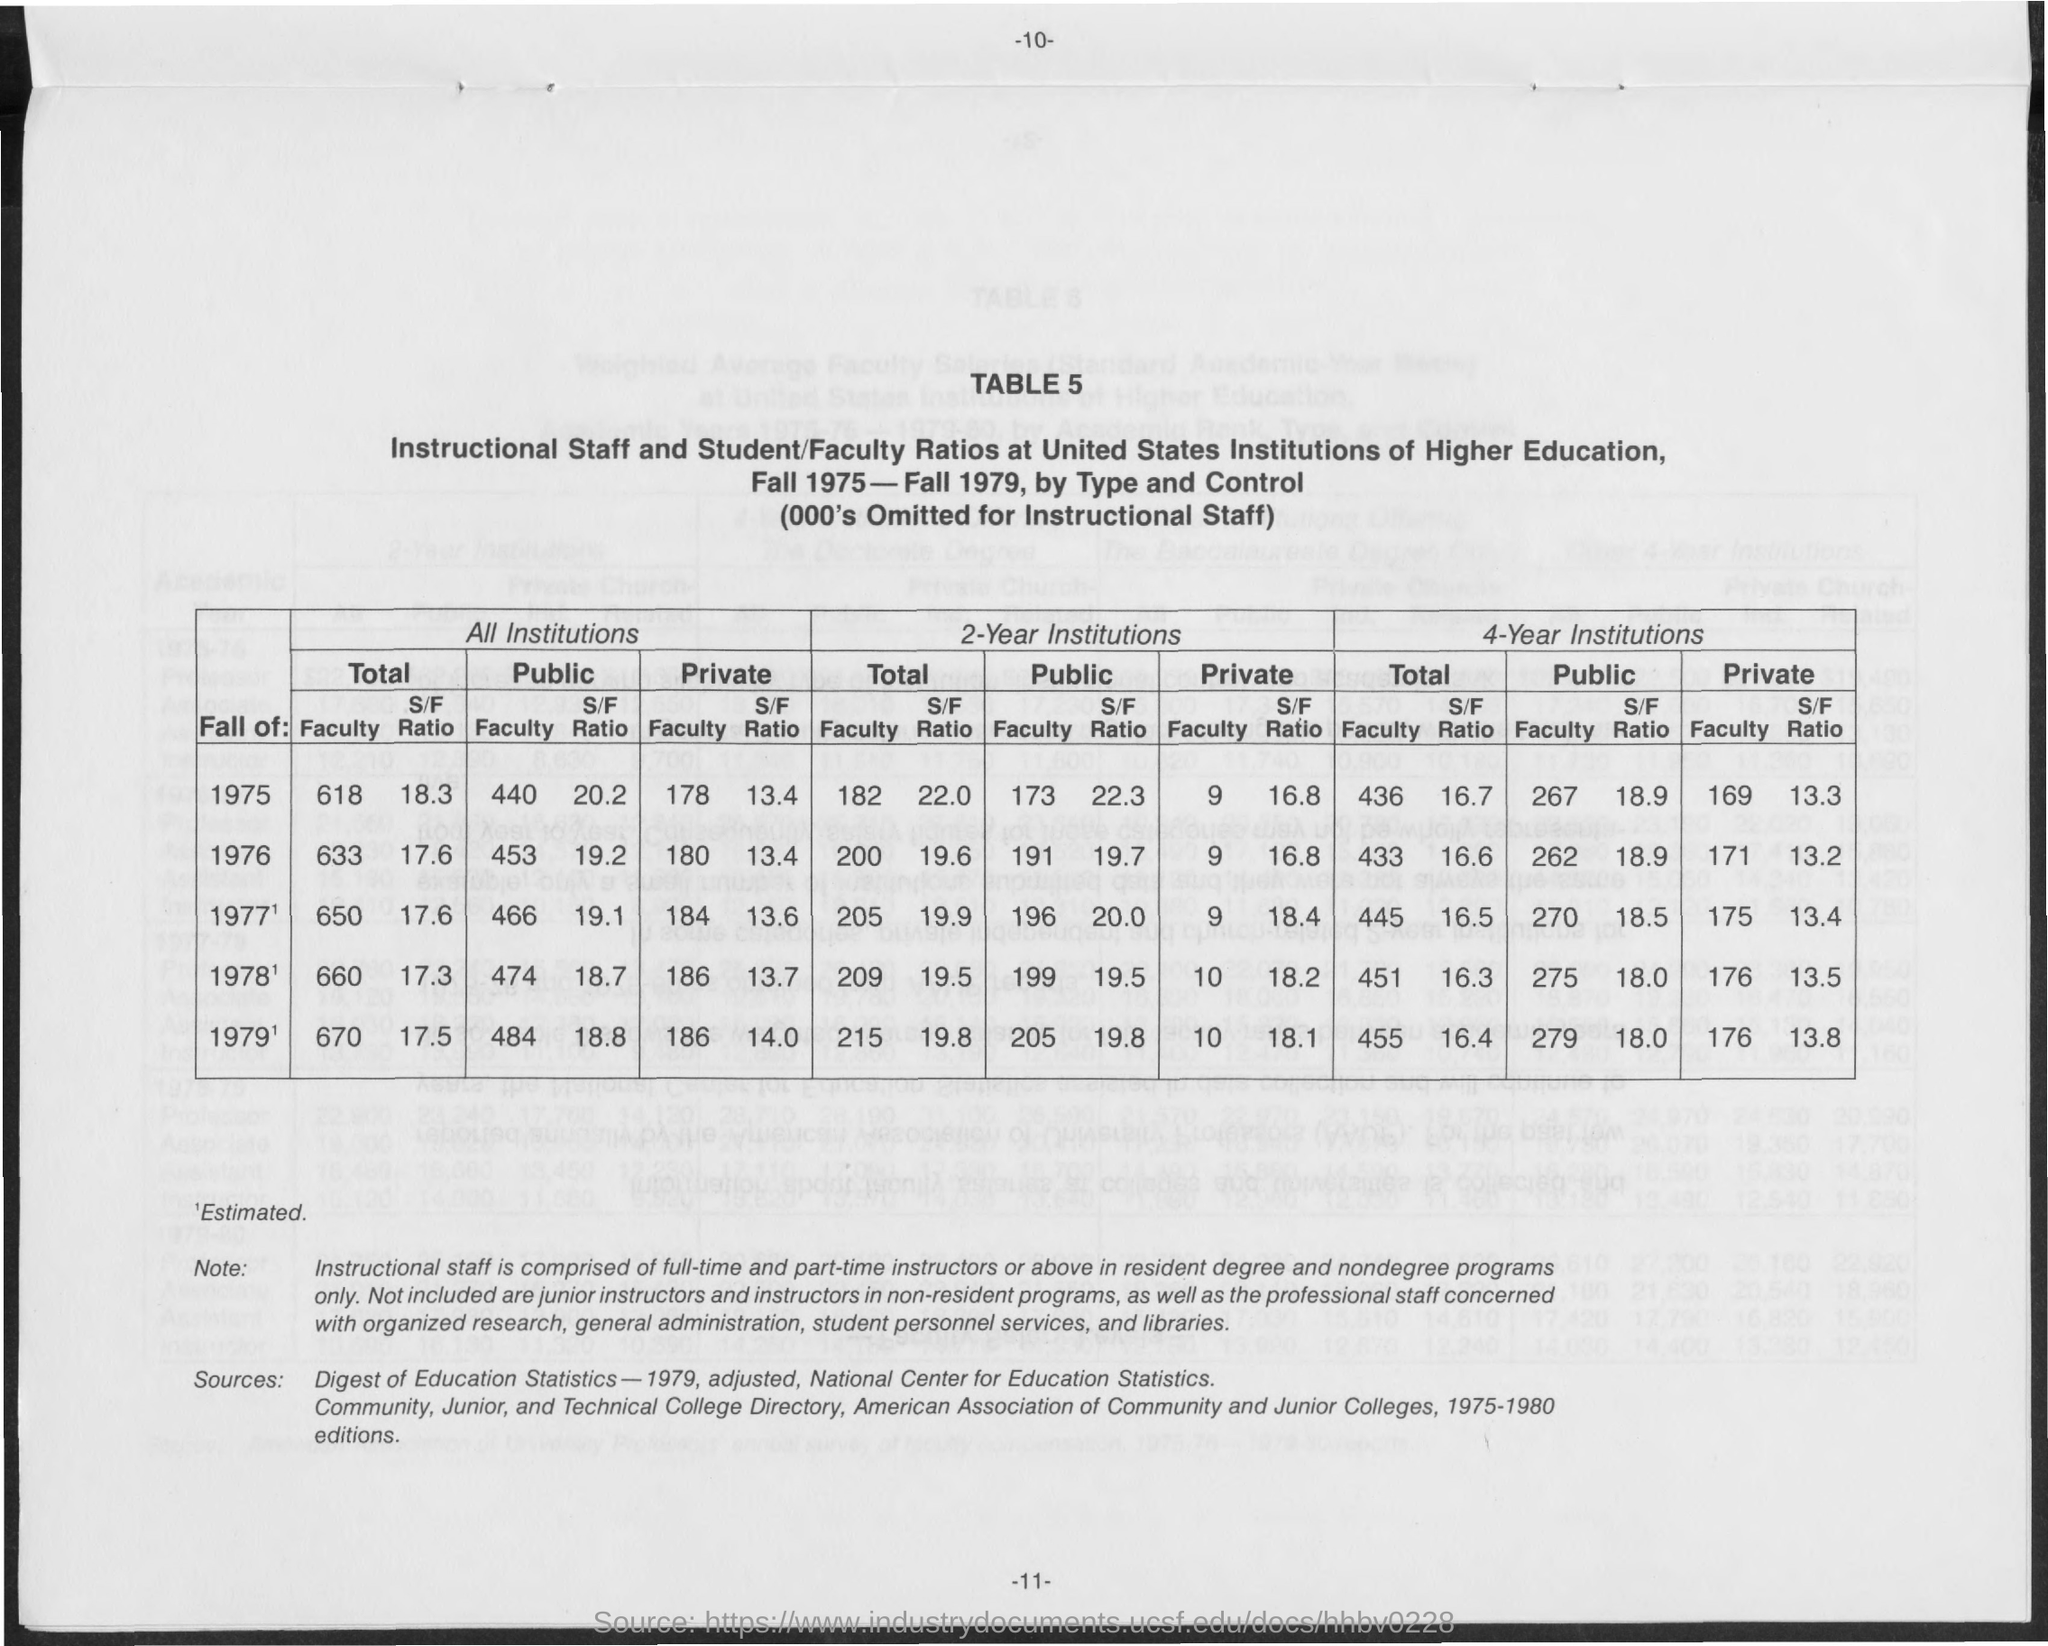What is the Page Number?
Provide a succinct answer. 11. 